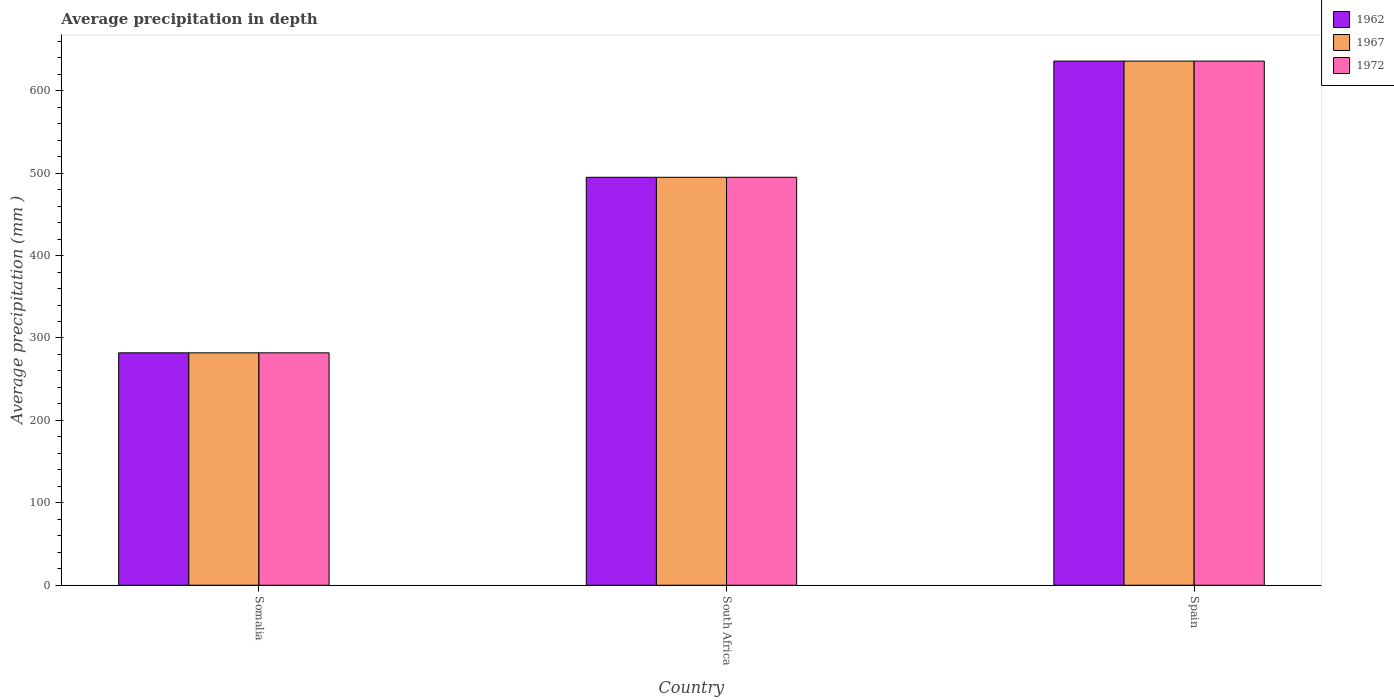How many groups of bars are there?
Ensure brevity in your answer.  3. Are the number of bars on each tick of the X-axis equal?
Keep it short and to the point. Yes. How many bars are there on the 2nd tick from the right?
Provide a short and direct response. 3. What is the label of the 2nd group of bars from the left?
Your answer should be very brief. South Africa. In how many cases, is the number of bars for a given country not equal to the number of legend labels?
Offer a terse response. 0. What is the average precipitation in 1967 in South Africa?
Provide a short and direct response. 495. Across all countries, what is the maximum average precipitation in 1962?
Your answer should be compact. 636. Across all countries, what is the minimum average precipitation in 1967?
Provide a succinct answer. 282. In which country was the average precipitation in 1967 maximum?
Give a very brief answer. Spain. In which country was the average precipitation in 1962 minimum?
Offer a very short reply. Somalia. What is the total average precipitation in 1967 in the graph?
Keep it short and to the point. 1413. What is the difference between the average precipitation in 1967 in Somalia and that in South Africa?
Offer a very short reply. -213. What is the difference between the average precipitation in 1972 in Somalia and the average precipitation in 1967 in Spain?
Make the answer very short. -354. What is the average average precipitation in 1962 per country?
Offer a very short reply. 471. In how many countries, is the average precipitation in 1962 greater than 60 mm?
Ensure brevity in your answer.  3. What is the ratio of the average precipitation in 1962 in Somalia to that in Spain?
Give a very brief answer. 0.44. Is the average precipitation in 1972 in Somalia less than that in South Africa?
Your answer should be very brief. Yes. Is the difference between the average precipitation in 1967 in South Africa and Spain greater than the difference between the average precipitation in 1962 in South Africa and Spain?
Offer a very short reply. No. What is the difference between the highest and the second highest average precipitation in 1972?
Provide a succinct answer. -354. What is the difference between the highest and the lowest average precipitation in 1967?
Make the answer very short. 354. What does the 2nd bar from the left in South Africa represents?
Your answer should be very brief. 1967. What does the 2nd bar from the right in Spain represents?
Make the answer very short. 1967. Are all the bars in the graph horizontal?
Your answer should be very brief. No. What is the difference between two consecutive major ticks on the Y-axis?
Your answer should be compact. 100. Are the values on the major ticks of Y-axis written in scientific E-notation?
Keep it short and to the point. No. Where does the legend appear in the graph?
Your answer should be very brief. Top right. How are the legend labels stacked?
Offer a terse response. Vertical. What is the title of the graph?
Your answer should be compact. Average precipitation in depth. Does "1994" appear as one of the legend labels in the graph?
Your response must be concise. No. What is the label or title of the Y-axis?
Provide a succinct answer. Average precipitation (mm ). What is the Average precipitation (mm ) in 1962 in Somalia?
Your answer should be very brief. 282. What is the Average precipitation (mm ) in 1967 in Somalia?
Ensure brevity in your answer.  282. What is the Average precipitation (mm ) in 1972 in Somalia?
Ensure brevity in your answer.  282. What is the Average precipitation (mm ) in 1962 in South Africa?
Provide a succinct answer. 495. What is the Average precipitation (mm ) in 1967 in South Africa?
Ensure brevity in your answer.  495. What is the Average precipitation (mm ) in 1972 in South Africa?
Ensure brevity in your answer.  495. What is the Average precipitation (mm ) of 1962 in Spain?
Ensure brevity in your answer.  636. What is the Average precipitation (mm ) in 1967 in Spain?
Ensure brevity in your answer.  636. What is the Average precipitation (mm ) of 1972 in Spain?
Your answer should be compact. 636. Across all countries, what is the maximum Average precipitation (mm ) in 1962?
Your response must be concise. 636. Across all countries, what is the maximum Average precipitation (mm ) in 1967?
Your answer should be very brief. 636. Across all countries, what is the maximum Average precipitation (mm ) of 1972?
Ensure brevity in your answer.  636. Across all countries, what is the minimum Average precipitation (mm ) in 1962?
Keep it short and to the point. 282. Across all countries, what is the minimum Average precipitation (mm ) in 1967?
Your response must be concise. 282. Across all countries, what is the minimum Average precipitation (mm ) in 1972?
Provide a succinct answer. 282. What is the total Average precipitation (mm ) of 1962 in the graph?
Provide a succinct answer. 1413. What is the total Average precipitation (mm ) in 1967 in the graph?
Make the answer very short. 1413. What is the total Average precipitation (mm ) in 1972 in the graph?
Offer a very short reply. 1413. What is the difference between the Average precipitation (mm ) of 1962 in Somalia and that in South Africa?
Your response must be concise. -213. What is the difference between the Average precipitation (mm ) of 1967 in Somalia and that in South Africa?
Provide a succinct answer. -213. What is the difference between the Average precipitation (mm ) in 1972 in Somalia and that in South Africa?
Ensure brevity in your answer.  -213. What is the difference between the Average precipitation (mm ) in 1962 in Somalia and that in Spain?
Offer a very short reply. -354. What is the difference between the Average precipitation (mm ) in 1967 in Somalia and that in Spain?
Your answer should be compact. -354. What is the difference between the Average precipitation (mm ) of 1972 in Somalia and that in Spain?
Give a very brief answer. -354. What is the difference between the Average precipitation (mm ) in 1962 in South Africa and that in Spain?
Your answer should be compact. -141. What is the difference between the Average precipitation (mm ) of 1967 in South Africa and that in Spain?
Offer a terse response. -141. What is the difference between the Average precipitation (mm ) in 1972 in South Africa and that in Spain?
Offer a terse response. -141. What is the difference between the Average precipitation (mm ) in 1962 in Somalia and the Average precipitation (mm ) in 1967 in South Africa?
Your response must be concise. -213. What is the difference between the Average precipitation (mm ) of 1962 in Somalia and the Average precipitation (mm ) of 1972 in South Africa?
Ensure brevity in your answer.  -213. What is the difference between the Average precipitation (mm ) of 1967 in Somalia and the Average precipitation (mm ) of 1972 in South Africa?
Your answer should be compact. -213. What is the difference between the Average precipitation (mm ) in 1962 in Somalia and the Average precipitation (mm ) in 1967 in Spain?
Give a very brief answer. -354. What is the difference between the Average precipitation (mm ) of 1962 in Somalia and the Average precipitation (mm ) of 1972 in Spain?
Provide a succinct answer. -354. What is the difference between the Average precipitation (mm ) of 1967 in Somalia and the Average precipitation (mm ) of 1972 in Spain?
Keep it short and to the point. -354. What is the difference between the Average precipitation (mm ) in 1962 in South Africa and the Average precipitation (mm ) in 1967 in Spain?
Make the answer very short. -141. What is the difference between the Average precipitation (mm ) of 1962 in South Africa and the Average precipitation (mm ) of 1972 in Spain?
Give a very brief answer. -141. What is the difference between the Average precipitation (mm ) in 1967 in South Africa and the Average precipitation (mm ) in 1972 in Spain?
Your answer should be compact. -141. What is the average Average precipitation (mm ) in 1962 per country?
Provide a short and direct response. 471. What is the average Average precipitation (mm ) of 1967 per country?
Your response must be concise. 471. What is the average Average precipitation (mm ) of 1972 per country?
Your response must be concise. 471. What is the difference between the Average precipitation (mm ) of 1962 and Average precipitation (mm ) of 1967 in Somalia?
Your answer should be very brief. 0. What is the difference between the Average precipitation (mm ) in 1962 and Average precipitation (mm ) in 1972 in Somalia?
Your response must be concise. 0. What is the difference between the Average precipitation (mm ) in 1962 and Average precipitation (mm ) in 1967 in South Africa?
Give a very brief answer. 0. What is the difference between the Average precipitation (mm ) of 1962 and Average precipitation (mm ) of 1967 in Spain?
Ensure brevity in your answer.  0. What is the difference between the Average precipitation (mm ) of 1962 and Average precipitation (mm ) of 1972 in Spain?
Offer a terse response. 0. What is the ratio of the Average precipitation (mm ) of 1962 in Somalia to that in South Africa?
Offer a very short reply. 0.57. What is the ratio of the Average precipitation (mm ) in 1967 in Somalia to that in South Africa?
Provide a short and direct response. 0.57. What is the ratio of the Average precipitation (mm ) of 1972 in Somalia to that in South Africa?
Your answer should be compact. 0.57. What is the ratio of the Average precipitation (mm ) in 1962 in Somalia to that in Spain?
Your answer should be very brief. 0.44. What is the ratio of the Average precipitation (mm ) in 1967 in Somalia to that in Spain?
Your answer should be compact. 0.44. What is the ratio of the Average precipitation (mm ) of 1972 in Somalia to that in Spain?
Give a very brief answer. 0.44. What is the ratio of the Average precipitation (mm ) in 1962 in South Africa to that in Spain?
Your answer should be compact. 0.78. What is the ratio of the Average precipitation (mm ) of 1967 in South Africa to that in Spain?
Provide a succinct answer. 0.78. What is the ratio of the Average precipitation (mm ) in 1972 in South Africa to that in Spain?
Your answer should be compact. 0.78. What is the difference between the highest and the second highest Average precipitation (mm ) in 1962?
Provide a succinct answer. 141. What is the difference between the highest and the second highest Average precipitation (mm ) in 1967?
Provide a short and direct response. 141. What is the difference between the highest and the second highest Average precipitation (mm ) of 1972?
Give a very brief answer. 141. What is the difference between the highest and the lowest Average precipitation (mm ) of 1962?
Provide a succinct answer. 354. What is the difference between the highest and the lowest Average precipitation (mm ) in 1967?
Your response must be concise. 354. What is the difference between the highest and the lowest Average precipitation (mm ) in 1972?
Your response must be concise. 354. 